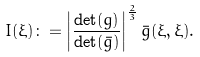Convert formula to latex. <formula><loc_0><loc_0><loc_500><loc_500>I ( \xi ) \colon = \left | \frac { \det ( g ) } { \det ( \bar { g } ) } \right | ^ { \frac { 2 } { 3 } } \bar { g } ( \xi , \xi ) .</formula> 